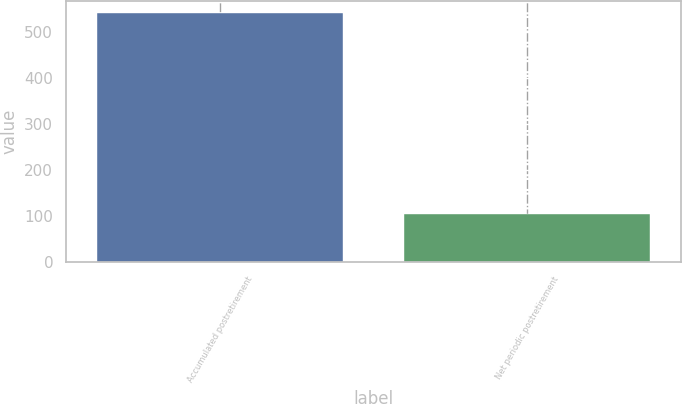Convert chart. <chart><loc_0><loc_0><loc_500><loc_500><bar_chart><fcel>Accumulated postretirement<fcel>Net periodic postretirement<nl><fcel>541<fcel>104<nl></chart> 